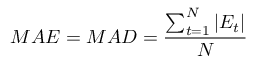<formula> <loc_0><loc_0><loc_500><loc_500>\ M A E = M A D = { \frac { \sum _ { t = 1 } ^ { N } | E _ { t } | } { N } }</formula> 